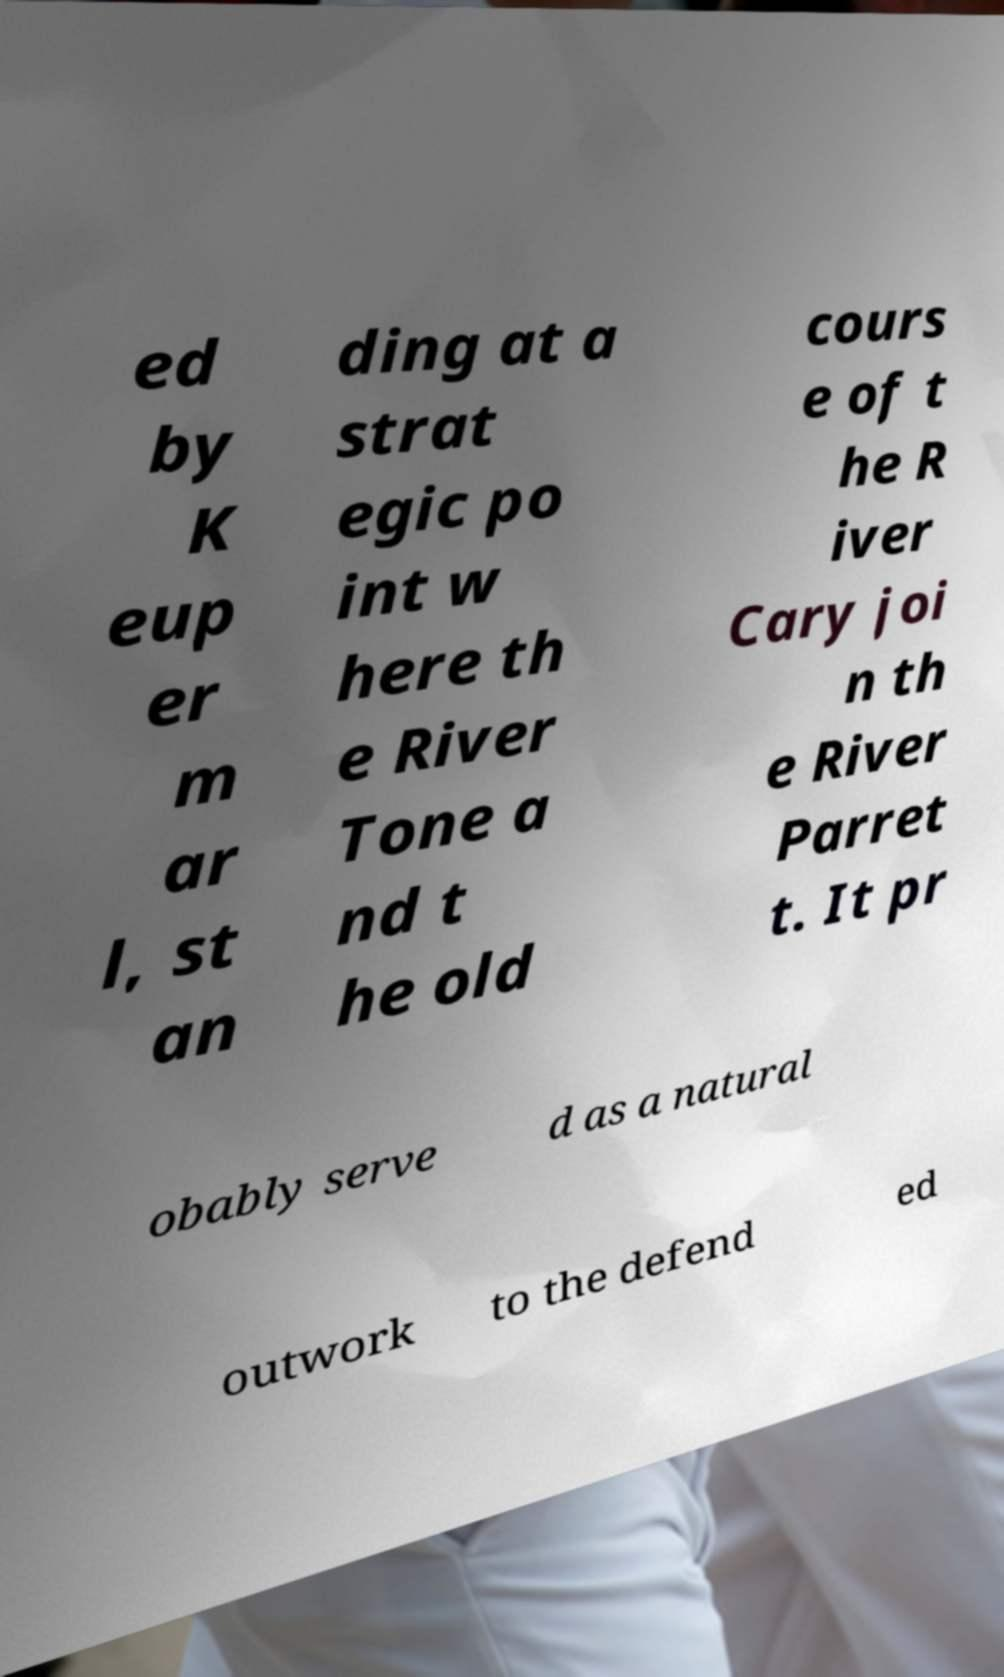Could you assist in decoding the text presented in this image and type it out clearly? ed by K eup er m ar l, st an ding at a strat egic po int w here th e River Tone a nd t he old cours e of t he R iver Cary joi n th e River Parret t. It pr obably serve d as a natural outwork to the defend ed 